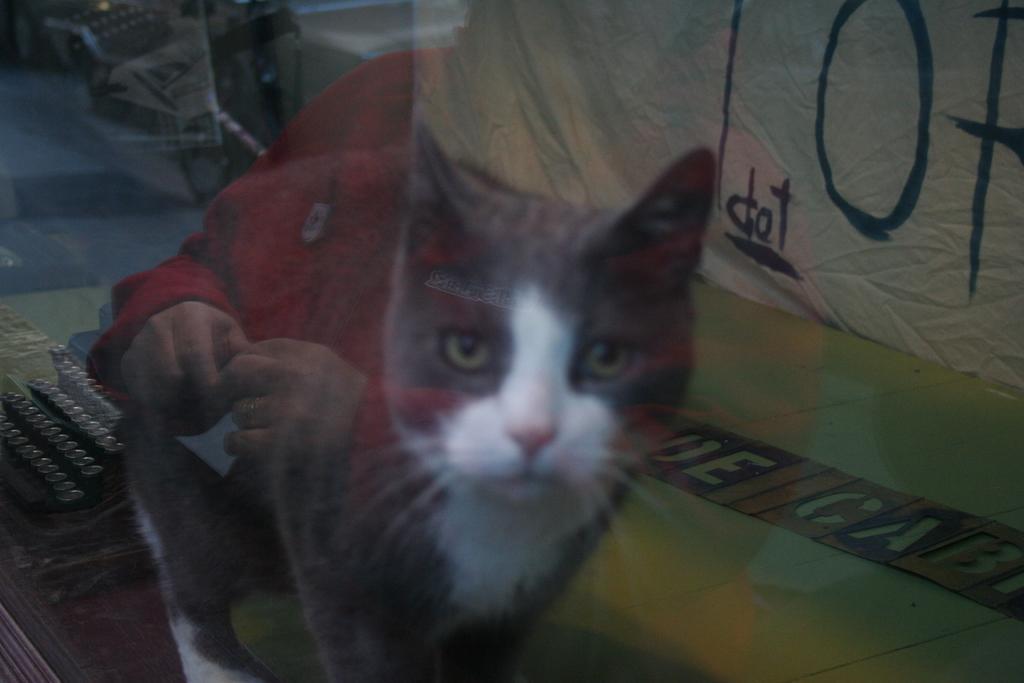How would you summarize this image in a sentence or two? In this picture we can see glass, through this glass we can see cat, person, banner and objects. 